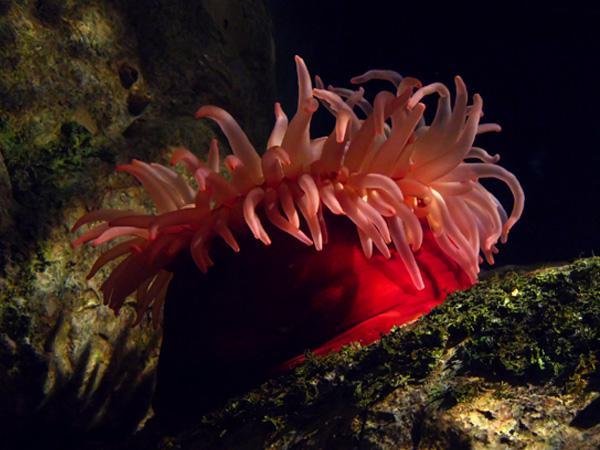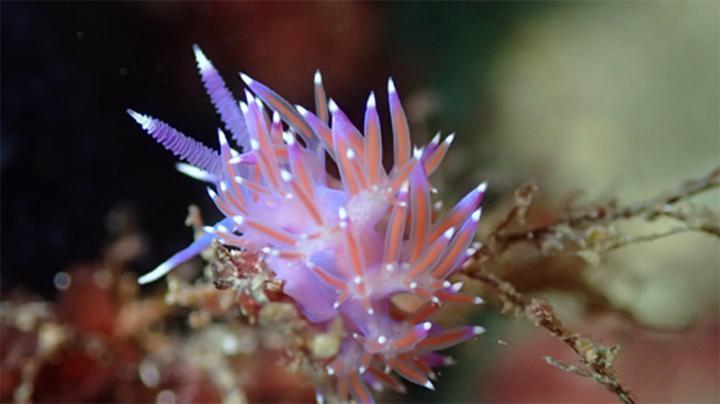The first image is the image on the left, the second image is the image on the right. Considering the images on both sides, is "There is a clownfish in at least one image." valid? Answer yes or no. No. The first image is the image on the left, the second image is the image on the right. Assess this claim about the two images: "there is a clown fish in the image on the right". Correct or not? Answer yes or no. No. 